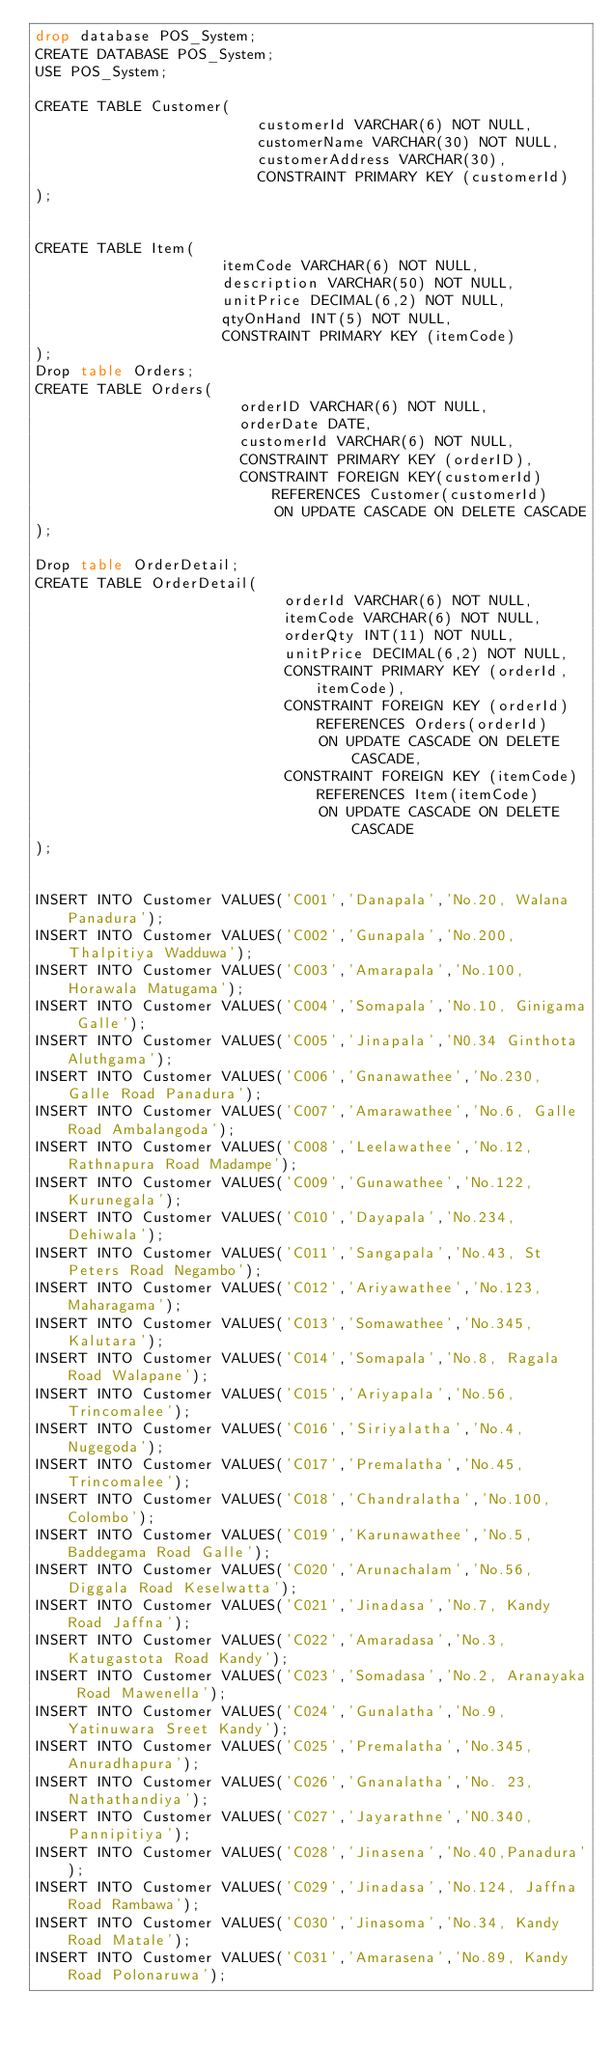<code> <loc_0><loc_0><loc_500><loc_500><_SQL_>drop database POS_System;
CREATE DATABASE POS_System;
USE POS_System;

CREATE TABLE Customer(
                         customerId VARCHAR(6) NOT NULL,
                         customerName VARCHAR(30) NOT NULL,
                         customerAddress VARCHAR(30),
                         CONSTRAINT PRIMARY KEY (customerId)
);


CREATE TABLE Item(
                     itemCode VARCHAR(6) NOT NULL,
                     description VARCHAR(50) NOT NULL,
                     unitPrice DECIMAL(6,2) NOT NULL,
                     qtyOnHand INT(5) NOT NULL,
                     CONSTRAINT PRIMARY KEY (itemCode)
);
Drop table Orders;
CREATE TABLE Orders(
                       orderID VARCHAR(6) NOT NULL,
                       orderDate DATE,
                       customerId VARCHAR(6) NOT NULL,
                       CONSTRAINT PRIMARY KEY (orderID),
                       CONSTRAINT FOREIGN KEY(customerId) REFERENCES Customer(customerId)
                           ON UPDATE CASCADE ON DELETE CASCADE
);

Drop table OrderDetail;
CREATE TABLE OrderDetail(
                            orderId VARCHAR(6) NOT NULL,
                            itemCode VARCHAR(6) NOT NULL,
                            orderQty INT(11) NOT NULL,
                            unitPrice DECIMAL(6,2) NOT NULL,
                            CONSTRAINT PRIMARY KEY (orderId,itemCode),
                            CONSTRAINT FOREIGN KEY (orderId) REFERENCES Orders(orderId)
                                ON UPDATE CASCADE ON DELETE CASCADE,
                            CONSTRAINT FOREIGN KEY (itemCode) REFERENCES Item(itemCode)
                                ON UPDATE CASCADE ON DELETE CASCADE
);


INSERT INTO Customer VALUES('C001','Danapala','No.20, Walana Panadura');
INSERT INTO Customer VALUES('C002','Gunapala','No.200, Thalpitiya Wadduwa');
INSERT INTO Customer VALUES('C003','Amarapala','No.100, Horawala Matugama');
INSERT INTO Customer VALUES('C004','Somapala','No.10, Ginigama Galle');
INSERT INTO Customer VALUES('C005','Jinapala','N0.34 Ginthota Aluthgama');
INSERT INTO Customer VALUES('C006','Gnanawathee','No.230, Galle Road Panadura');
INSERT INTO Customer VALUES('C007','Amarawathee','No.6, Galle Road Ambalangoda');
INSERT INTO Customer VALUES('C008','Leelawathee','No.12, Rathnapura Road Madampe');
INSERT INTO Customer VALUES('C009','Gunawathee','No.122, Kurunegala');
INSERT INTO Customer VALUES('C010','Dayapala','No.234, Dehiwala');
INSERT INTO Customer VALUES('C011','Sangapala','No.43, St Peters Road Negambo');
INSERT INTO Customer VALUES('C012','Ariyawathee','No.123, Maharagama');
INSERT INTO Customer VALUES('C013','Somawathee','No.345, Kalutara');
INSERT INTO Customer VALUES('C014','Somapala','No.8, Ragala Road Walapane');
INSERT INTO Customer VALUES('C015','Ariyapala','No.56, Trincomalee');
INSERT INTO Customer VALUES('C016','Siriyalatha','No.4, Nugegoda');
INSERT INTO Customer VALUES('C017','Premalatha','No.45, Trincomalee');
INSERT INTO Customer VALUES('C018','Chandralatha','No.100, Colombo');
INSERT INTO Customer VALUES('C019','Karunawathee','No.5, Baddegama Road Galle');
INSERT INTO Customer VALUES('C020','Arunachalam','No.56, Diggala Road Keselwatta');
INSERT INTO Customer VALUES('C021','Jinadasa','No.7, Kandy Road Jaffna');
INSERT INTO Customer VALUES('C022','Amaradasa','No.3, Katugastota Road Kandy');
INSERT INTO Customer VALUES('C023','Somadasa','No.2, Aranayaka Road Mawenella');
INSERT INTO Customer VALUES('C024','Gunalatha','No.9, Yatinuwara Sreet Kandy');
INSERT INTO Customer VALUES('C025','Premalatha','No.345, Anuradhapura');
INSERT INTO Customer VALUES('C026','Gnanalatha','No. 23,Nathathandiya');
INSERT INTO Customer VALUES('C027','Jayarathne','N0.340, Pannipitiya');
INSERT INTO Customer VALUES('C028','Jinasena','No.40,Panadura');
INSERT INTO Customer VALUES('C029','Jinadasa','No.124, Jaffna Road Rambawa');
INSERT INTO Customer VALUES('C030','Jinasoma','No.34, Kandy Road Matale');
INSERT INTO Customer VALUES('C031','Amarasena','No.89, Kandy Road Polonaruwa');</code> 